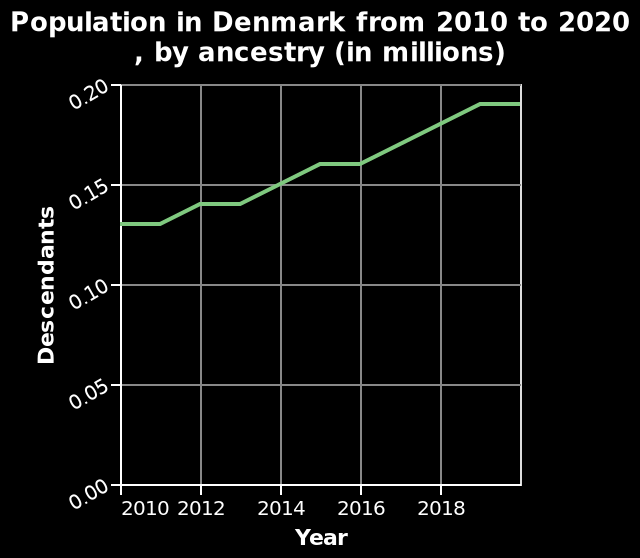<image>
What is the trend of the population over the last 10 years? The trend of the population over the last 10 years has been a steady increase. 